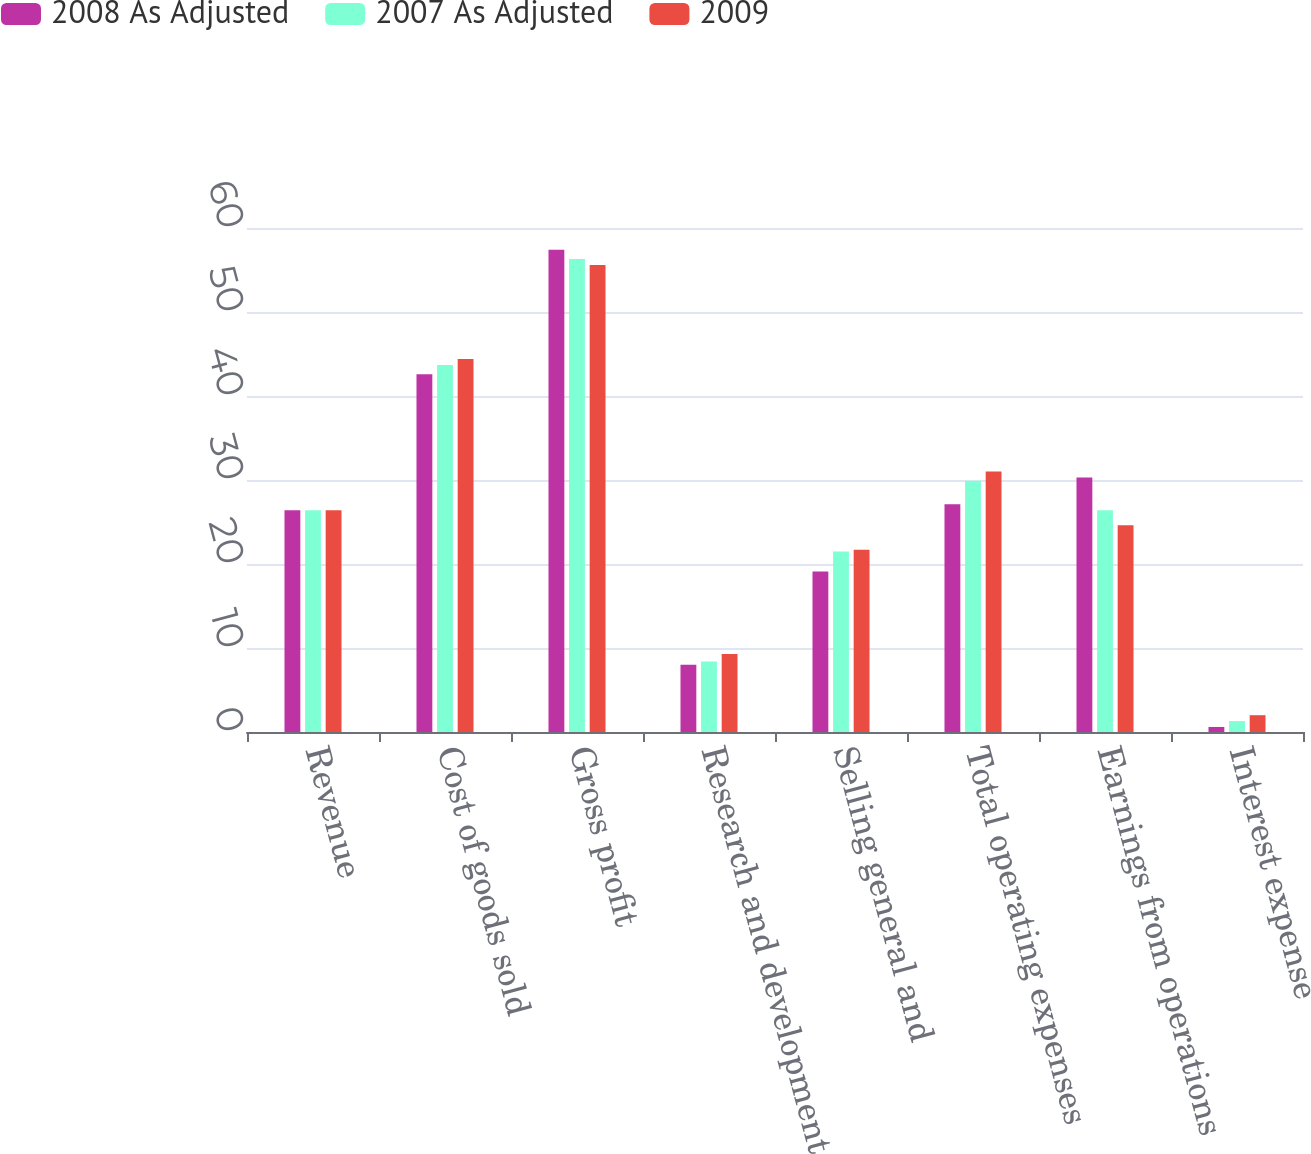Convert chart to OTSL. <chart><loc_0><loc_0><loc_500><loc_500><stacked_bar_chart><ecel><fcel>Revenue<fcel>Cost of goods sold<fcel>Gross profit<fcel>Research and development<fcel>Selling general and<fcel>Total operating expenses<fcel>Earnings from operations<fcel>Interest expense<nl><fcel>2008 As Adjusted<fcel>26.4<fcel>42.6<fcel>57.4<fcel>8<fcel>19.1<fcel>27.1<fcel>30.3<fcel>0.6<nl><fcel>2007 As Adjusted<fcel>26.4<fcel>43.7<fcel>56.3<fcel>8.4<fcel>21.5<fcel>29.9<fcel>26.4<fcel>1.3<nl><fcel>2009<fcel>26.4<fcel>44.4<fcel>55.6<fcel>9.3<fcel>21.7<fcel>31<fcel>24.6<fcel>2<nl></chart> 